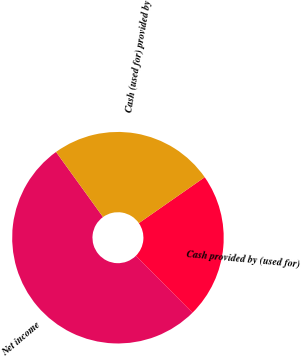Convert chart. <chart><loc_0><loc_0><loc_500><loc_500><pie_chart><fcel>Net income<fcel>Cash provided by (used for)<fcel>Cash (used for) provided by<nl><fcel>52.5%<fcel>22.24%<fcel>25.26%<nl></chart> 